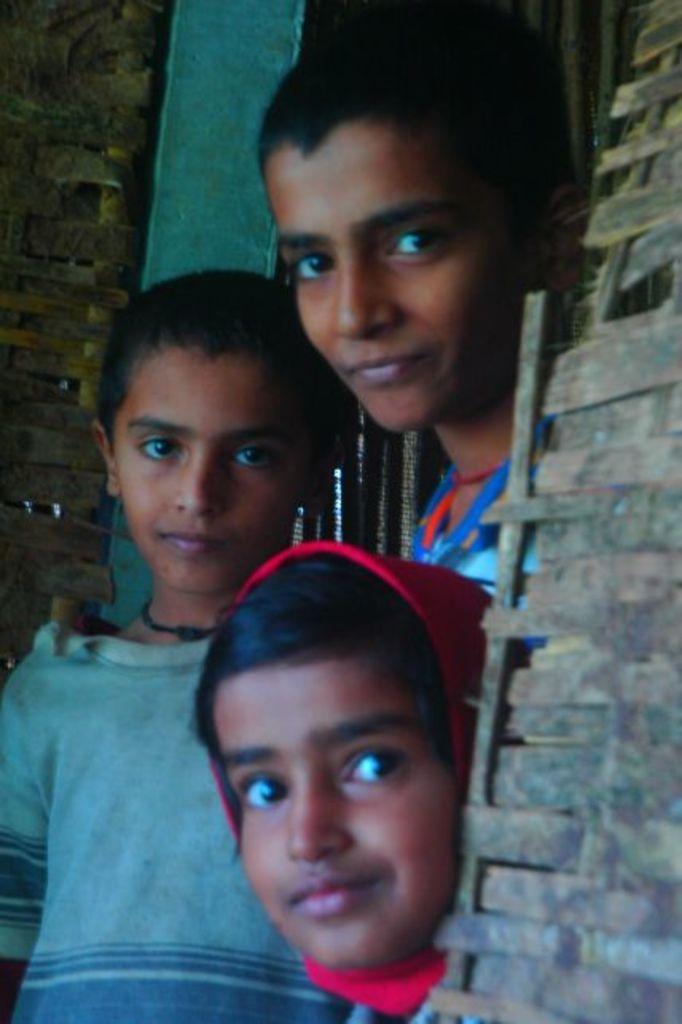Please provide a concise description of this image. In this image I can see a person wearing blue t shirt and another person wearing red colored cloth to the head and another boy wearing blue dress are standing and in the background I can see the blue colored thing and the wooden wall. 